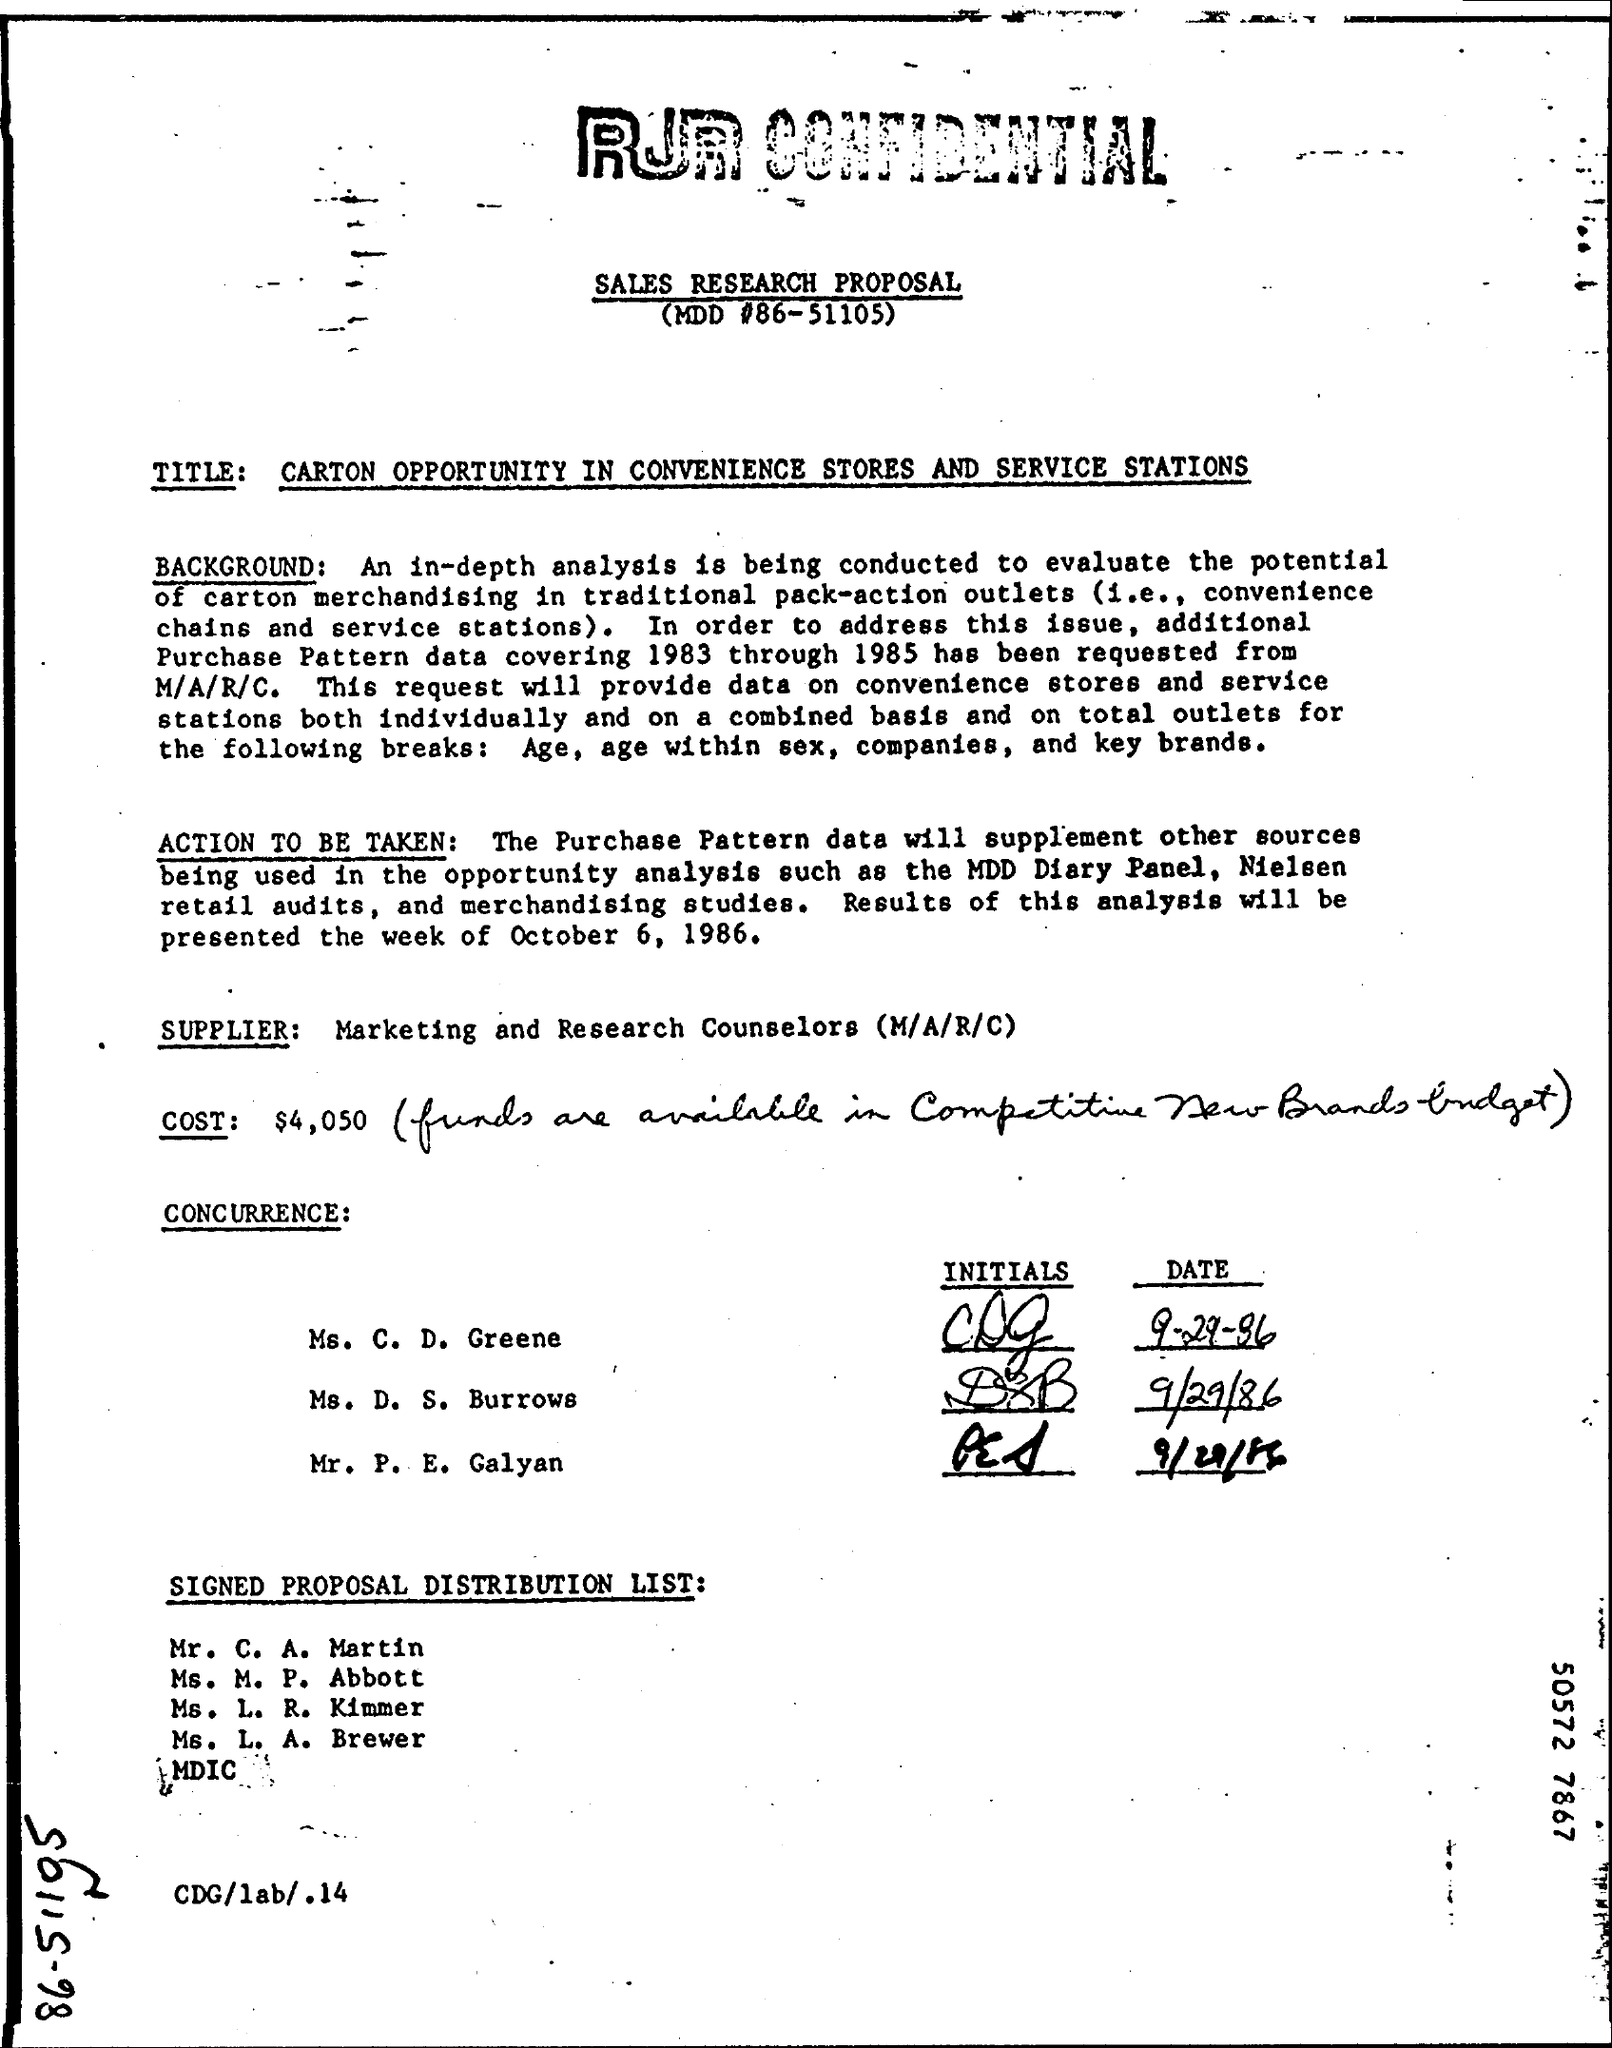What is the value of cost as mentioned in the given proposal ?
Make the answer very short. $ 4,050. 